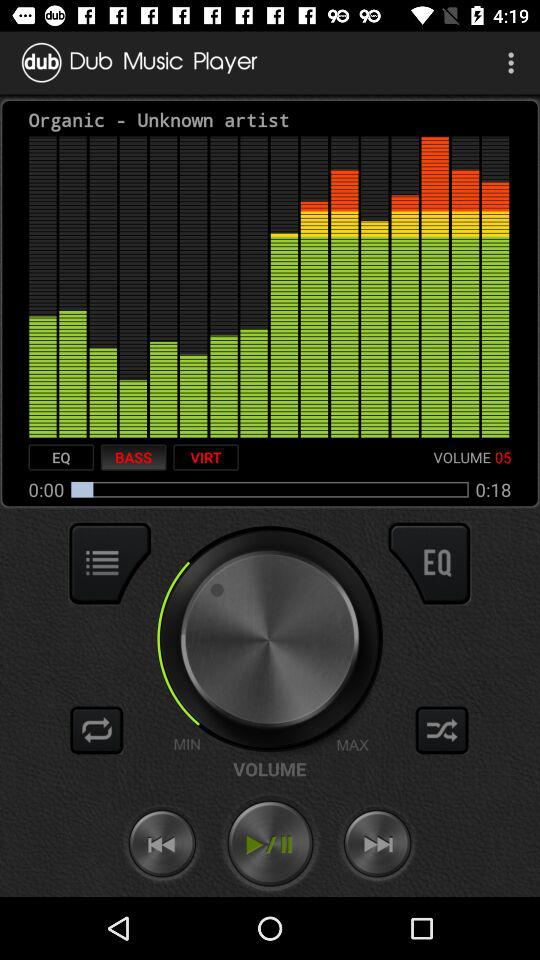How many more seconds are there in the song than in the remaining time?
Answer the question using a single word or phrase. 18 